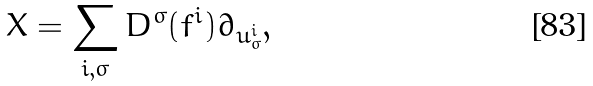Convert formula to latex. <formula><loc_0><loc_0><loc_500><loc_500>X = \sum _ { i , \sigma } D ^ { \sigma } ( f ^ { i } ) \partial _ { u ^ { i } _ { \sigma } } ,</formula> 